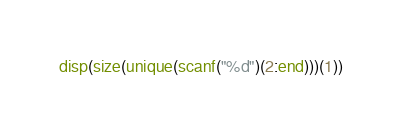Convert code to text. <code><loc_0><loc_0><loc_500><loc_500><_Octave_>disp(size(unique(scanf("%d")(2:end)))(1))</code> 